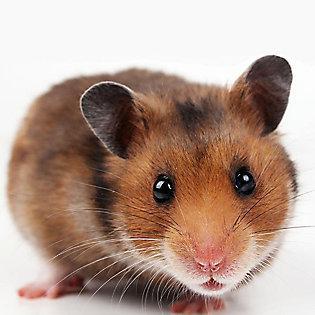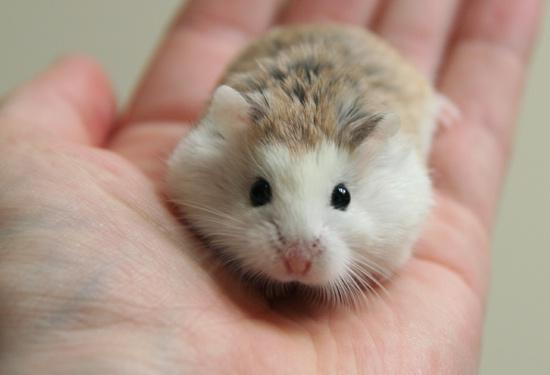The first image is the image on the left, the second image is the image on the right. Considering the images on both sides, is "At least one hamster is sitting in someone's hand." valid? Answer yes or no. Yes. 